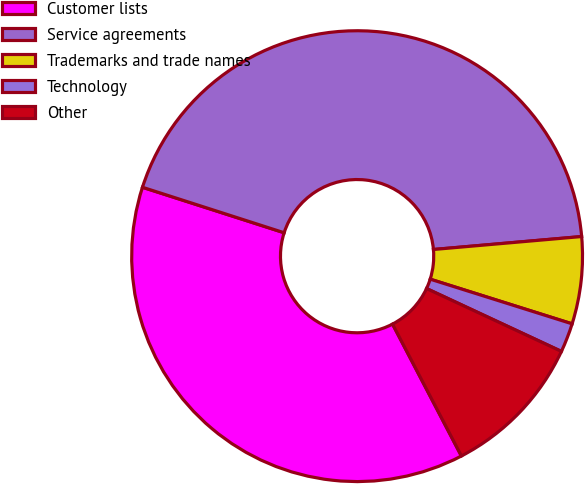<chart> <loc_0><loc_0><loc_500><loc_500><pie_chart><fcel>Customer lists<fcel>Service agreements<fcel>Trademarks and trade names<fcel>Technology<fcel>Other<nl><fcel>37.6%<fcel>43.67%<fcel>6.24%<fcel>2.09%<fcel>10.4%<nl></chart> 